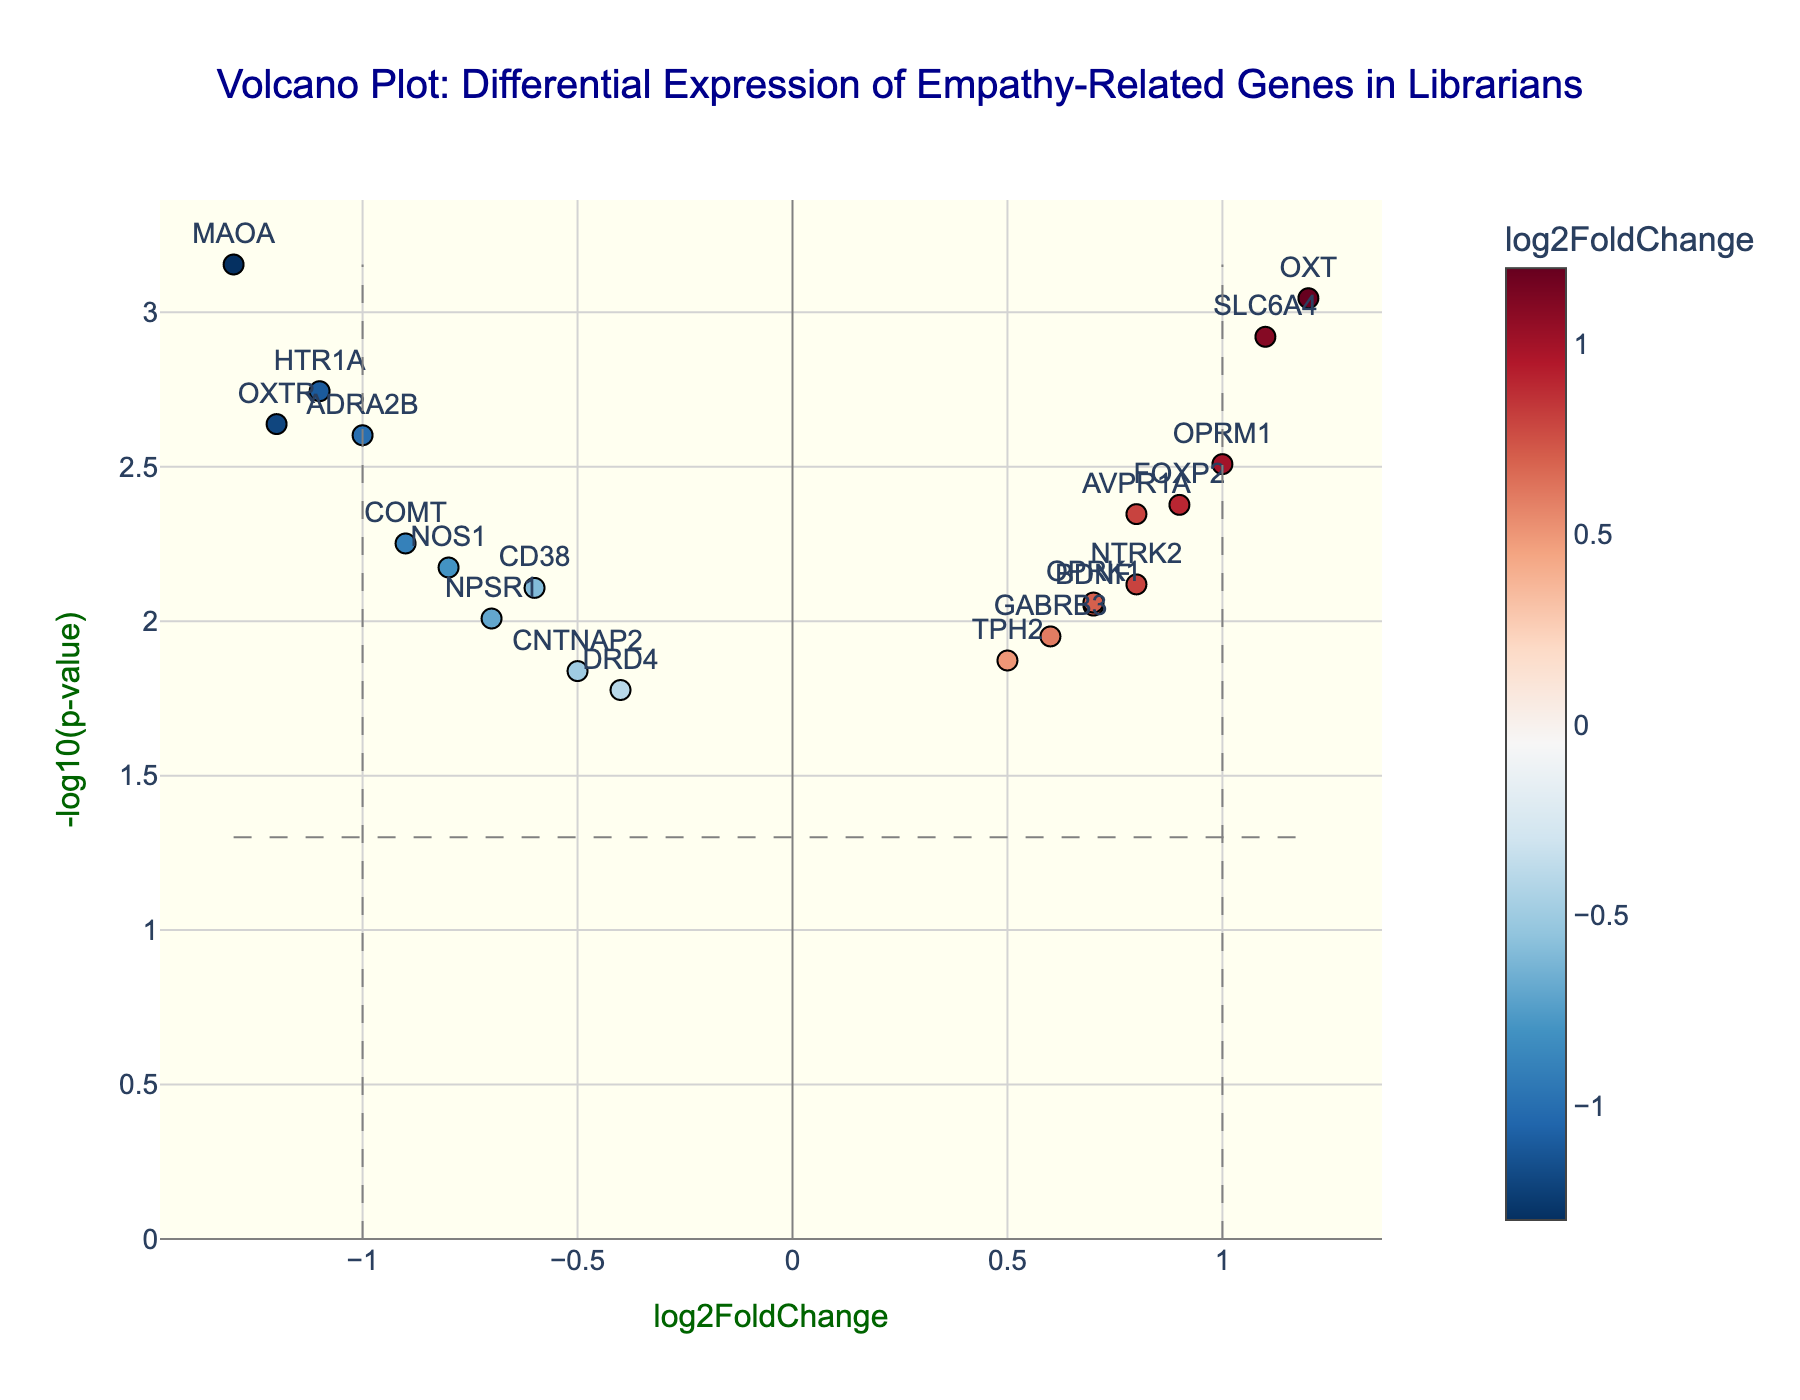what is the title of the plot? The title is found at the top center of the plot. It reads "Volcano Plot: Differential Expression of Empathy-Related Genes in Librarians."
Answer: Volcano Plot: Differential Expression of Empathy-Related Genes in Librarians Which axis represents the log2FoldChange? The x-axis represents the log2FoldChange. This is indicated by the label "log2FoldChange" on the x-axis at the bottom of the plot.
Answer: x-axis What does the color of the points indicate in the figure? The color of the points indicates the log2FoldChange value, with a color bar on the right side of the plot denoting this relationship. Different colors represent various ranges of log2FoldChange.
Answer: log2FoldChange value How many genes have a log2FoldChange greater than 1? To determine this, look for points that are to the right of the vertical line at x=1. There are two points that meet this criterion, corresponding to genes SLC6A4 and OXT.
Answer: 2 Which gene has the highest -log10(p-value)? The highest -log10(p-value) is marked by the highest point on the vertical axis. For this plot, it corresponds to the gene MAOA.
Answer: MAOA What is the log2FoldChange and p-value of the gene OXTR? The gene OXTR is labeled directly on the plot. From the hover text associated with its point, we see its log2FoldChange is -1.2 and its p-value is 0.0023.
Answer: log2FoldChange: -1.2, p-value: 0.0023 How many genes have p-values less than 0.05? In a volcano plot, points above the horizontal line at y=-log10(0.05) have p-values less than 0.05. We count the points above this line; there are 20 such points.
Answer: 20 Which gene has the largest negative log2FoldChange? By looking at the extreme left of the x-axis, the gene with the largest negative log2FoldChange is MAOA with a log2FoldChange of -1.3.
Answer: MAOA Compare the log2FoldChange values of genes DRD4 and SLC6A4. Which one is higher? We locate the genes DRD4 and SLC6A4 on the plot. DRD4 has a log2FoldChange of -0.4, and SLC6A4 has a log2FoldChange of 1.1. Thus, SLC6A4 has the higher value.
Answer: SLC6A4 Which genes are highlighted as not significant with p-values greater than 0.05? In a volcano plot, genes with p-values greater than 0.05 fall below the horizontal line at y=-log10(0.05). Points specifically below this line are considered not significant. For this plot, no genes fall in this category.
Answer: None 